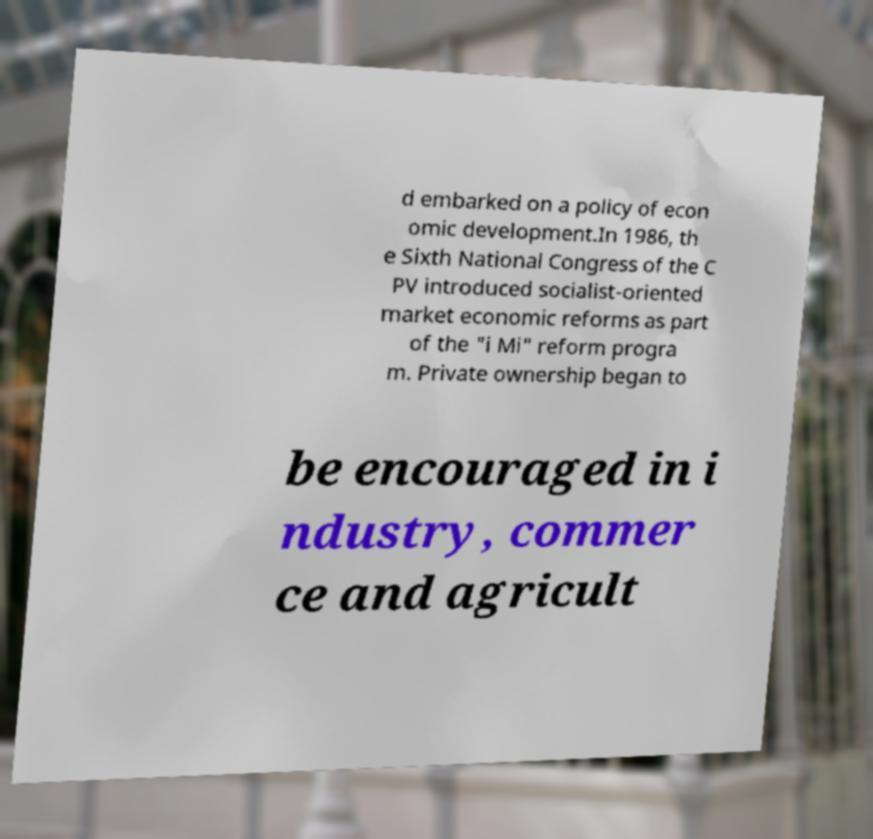There's text embedded in this image that I need extracted. Can you transcribe it verbatim? d embarked on a policy of econ omic development.In 1986, th e Sixth National Congress of the C PV introduced socialist-oriented market economic reforms as part of the "i Mi" reform progra m. Private ownership began to be encouraged in i ndustry, commer ce and agricult 